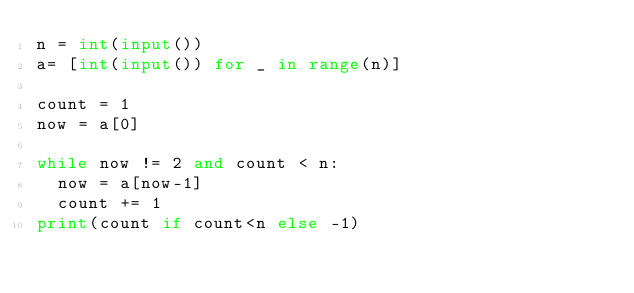<code> <loc_0><loc_0><loc_500><loc_500><_Python_>n = int(input())
a= [int(input()) for _ in range(n)]

count = 1
now = a[0]

while now != 2 and count < n:
  now = a[now-1]
  count += 1
print(count if count<n else -1)</code> 